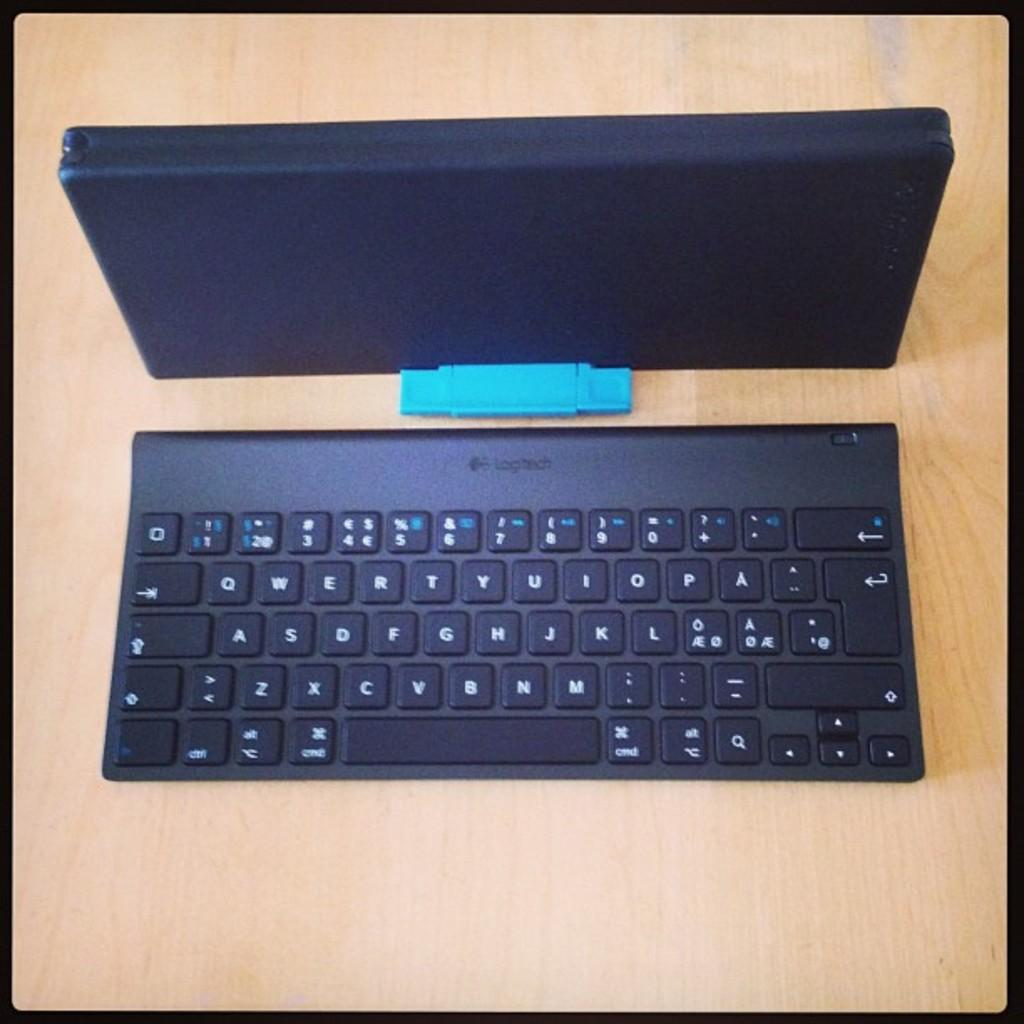Provide a one-sentence caption for the provided image. A Logitech black keyboard sitting on a desk. 